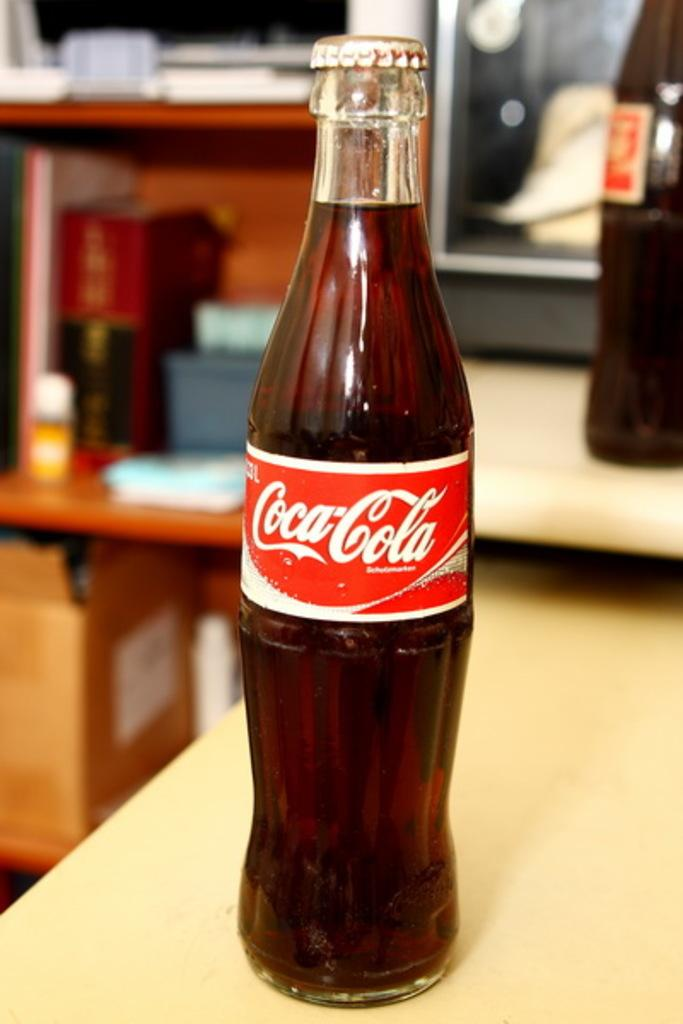What type of beverage container is in the image? There is a Coca-Cola bottle in the image. Where is the Coca-Cola bottle located? The Coca-Cola bottle is on a table. How many icicles are hanging from the Coca-Cola bottle in the image? There are no icicles present in the image, as it features a Coca-Cola bottle on a table. 